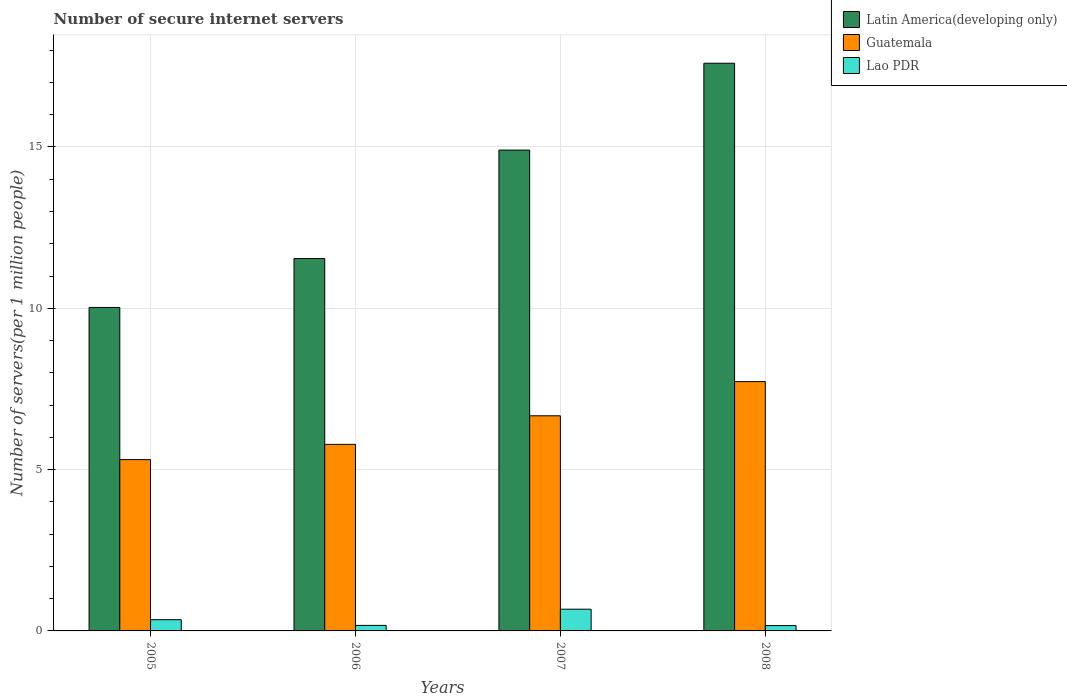Are the number of bars per tick equal to the number of legend labels?
Make the answer very short. Yes. Are the number of bars on each tick of the X-axis equal?
Provide a succinct answer. Yes. How many bars are there on the 2nd tick from the right?
Provide a succinct answer. 3. What is the number of secure internet servers in Guatemala in 2005?
Keep it short and to the point. 5.31. Across all years, what is the maximum number of secure internet servers in Guatemala?
Your response must be concise. 7.73. Across all years, what is the minimum number of secure internet servers in Guatemala?
Your answer should be very brief. 5.31. What is the total number of secure internet servers in Latin America(developing only) in the graph?
Your answer should be very brief. 54.06. What is the difference between the number of secure internet servers in Guatemala in 2005 and that in 2007?
Give a very brief answer. -1.36. What is the difference between the number of secure internet servers in Latin America(developing only) in 2008 and the number of secure internet servers in Lao PDR in 2006?
Your answer should be very brief. 17.42. What is the average number of secure internet servers in Latin America(developing only) per year?
Your answer should be compact. 13.52. In the year 2006, what is the difference between the number of secure internet servers in Guatemala and number of secure internet servers in Lao PDR?
Offer a terse response. 5.61. What is the ratio of the number of secure internet servers in Lao PDR in 2005 to that in 2008?
Your answer should be compact. 2.1. Is the number of secure internet servers in Guatemala in 2005 less than that in 2006?
Keep it short and to the point. Yes. What is the difference between the highest and the second highest number of secure internet servers in Latin America(developing only)?
Keep it short and to the point. 2.69. What is the difference between the highest and the lowest number of secure internet servers in Guatemala?
Your answer should be compact. 2.42. In how many years, is the number of secure internet servers in Latin America(developing only) greater than the average number of secure internet servers in Latin America(developing only) taken over all years?
Make the answer very short. 2. What does the 3rd bar from the left in 2007 represents?
Give a very brief answer. Lao PDR. What does the 2nd bar from the right in 2006 represents?
Your response must be concise. Guatemala. How many bars are there?
Ensure brevity in your answer.  12. Are all the bars in the graph horizontal?
Ensure brevity in your answer.  No. Does the graph contain grids?
Keep it short and to the point. Yes. How many legend labels are there?
Your answer should be compact. 3. What is the title of the graph?
Offer a terse response. Number of secure internet servers. What is the label or title of the Y-axis?
Offer a terse response. Number of servers(per 1 million people). What is the Number of servers(per 1 million people) of Latin America(developing only) in 2005?
Offer a very short reply. 10.03. What is the Number of servers(per 1 million people) in Guatemala in 2005?
Make the answer very short. 5.31. What is the Number of servers(per 1 million people) of Lao PDR in 2005?
Give a very brief answer. 0.35. What is the Number of servers(per 1 million people) of Latin America(developing only) in 2006?
Make the answer very short. 11.54. What is the Number of servers(per 1 million people) of Guatemala in 2006?
Offer a terse response. 5.78. What is the Number of servers(per 1 million people) in Lao PDR in 2006?
Provide a short and direct response. 0.17. What is the Number of servers(per 1 million people) in Latin America(developing only) in 2007?
Provide a short and direct response. 14.9. What is the Number of servers(per 1 million people) of Guatemala in 2007?
Your answer should be compact. 6.67. What is the Number of servers(per 1 million people) of Lao PDR in 2007?
Offer a very short reply. 0.67. What is the Number of servers(per 1 million people) of Latin America(developing only) in 2008?
Make the answer very short. 17.59. What is the Number of servers(per 1 million people) in Guatemala in 2008?
Provide a succinct answer. 7.73. What is the Number of servers(per 1 million people) of Lao PDR in 2008?
Offer a terse response. 0.17. Across all years, what is the maximum Number of servers(per 1 million people) of Latin America(developing only)?
Offer a terse response. 17.59. Across all years, what is the maximum Number of servers(per 1 million people) of Guatemala?
Your answer should be very brief. 7.73. Across all years, what is the maximum Number of servers(per 1 million people) of Lao PDR?
Give a very brief answer. 0.67. Across all years, what is the minimum Number of servers(per 1 million people) in Latin America(developing only)?
Your response must be concise. 10.03. Across all years, what is the minimum Number of servers(per 1 million people) in Guatemala?
Ensure brevity in your answer.  5.31. Across all years, what is the minimum Number of servers(per 1 million people) in Lao PDR?
Provide a succinct answer. 0.17. What is the total Number of servers(per 1 million people) of Latin America(developing only) in the graph?
Ensure brevity in your answer.  54.06. What is the total Number of servers(per 1 million people) of Guatemala in the graph?
Offer a very short reply. 25.49. What is the total Number of servers(per 1 million people) of Lao PDR in the graph?
Give a very brief answer. 1.36. What is the difference between the Number of servers(per 1 million people) in Latin America(developing only) in 2005 and that in 2006?
Your answer should be compact. -1.52. What is the difference between the Number of servers(per 1 million people) of Guatemala in 2005 and that in 2006?
Give a very brief answer. -0.47. What is the difference between the Number of servers(per 1 million people) of Lao PDR in 2005 and that in 2006?
Ensure brevity in your answer.  0.18. What is the difference between the Number of servers(per 1 million people) in Latin America(developing only) in 2005 and that in 2007?
Your answer should be very brief. -4.88. What is the difference between the Number of servers(per 1 million people) of Guatemala in 2005 and that in 2007?
Your response must be concise. -1.36. What is the difference between the Number of servers(per 1 million people) in Lao PDR in 2005 and that in 2007?
Make the answer very short. -0.33. What is the difference between the Number of servers(per 1 million people) of Latin America(developing only) in 2005 and that in 2008?
Your answer should be compact. -7.57. What is the difference between the Number of servers(per 1 million people) in Guatemala in 2005 and that in 2008?
Provide a short and direct response. -2.42. What is the difference between the Number of servers(per 1 million people) of Lao PDR in 2005 and that in 2008?
Keep it short and to the point. 0.18. What is the difference between the Number of servers(per 1 million people) of Latin America(developing only) in 2006 and that in 2007?
Provide a short and direct response. -3.36. What is the difference between the Number of servers(per 1 million people) of Guatemala in 2006 and that in 2007?
Give a very brief answer. -0.89. What is the difference between the Number of servers(per 1 million people) of Lao PDR in 2006 and that in 2007?
Provide a short and direct response. -0.5. What is the difference between the Number of servers(per 1 million people) of Latin America(developing only) in 2006 and that in 2008?
Your answer should be very brief. -6.05. What is the difference between the Number of servers(per 1 million people) in Guatemala in 2006 and that in 2008?
Provide a succinct answer. -1.94. What is the difference between the Number of servers(per 1 million people) of Lao PDR in 2006 and that in 2008?
Provide a short and direct response. 0.01. What is the difference between the Number of servers(per 1 million people) of Latin America(developing only) in 2007 and that in 2008?
Give a very brief answer. -2.69. What is the difference between the Number of servers(per 1 million people) of Guatemala in 2007 and that in 2008?
Offer a very short reply. -1.06. What is the difference between the Number of servers(per 1 million people) of Lao PDR in 2007 and that in 2008?
Offer a very short reply. 0.51. What is the difference between the Number of servers(per 1 million people) in Latin America(developing only) in 2005 and the Number of servers(per 1 million people) in Guatemala in 2006?
Ensure brevity in your answer.  4.24. What is the difference between the Number of servers(per 1 million people) of Latin America(developing only) in 2005 and the Number of servers(per 1 million people) of Lao PDR in 2006?
Make the answer very short. 9.85. What is the difference between the Number of servers(per 1 million people) of Guatemala in 2005 and the Number of servers(per 1 million people) of Lao PDR in 2006?
Your answer should be very brief. 5.14. What is the difference between the Number of servers(per 1 million people) in Latin America(developing only) in 2005 and the Number of servers(per 1 million people) in Guatemala in 2007?
Give a very brief answer. 3.36. What is the difference between the Number of servers(per 1 million people) of Latin America(developing only) in 2005 and the Number of servers(per 1 million people) of Lao PDR in 2007?
Ensure brevity in your answer.  9.35. What is the difference between the Number of servers(per 1 million people) of Guatemala in 2005 and the Number of servers(per 1 million people) of Lao PDR in 2007?
Keep it short and to the point. 4.64. What is the difference between the Number of servers(per 1 million people) in Latin America(developing only) in 2005 and the Number of servers(per 1 million people) in Guatemala in 2008?
Your answer should be compact. 2.3. What is the difference between the Number of servers(per 1 million people) in Latin America(developing only) in 2005 and the Number of servers(per 1 million people) in Lao PDR in 2008?
Your answer should be compact. 9.86. What is the difference between the Number of servers(per 1 million people) of Guatemala in 2005 and the Number of servers(per 1 million people) of Lao PDR in 2008?
Your answer should be very brief. 5.14. What is the difference between the Number of servers(per 1 million people) of Latin America(developing only) in 2006 and the Number of servers(per 1 million people) of Guatemala in 2007?
Your response must be concise. 4.87. What is the difference between the Number of servers(per 1 million people) of Latin America(developing only) in 2006 and the Number of servers(per 1 million people) of Lao PDR in 2007?
Your answer should be compact. 10.87. What is the difference between the Number of servers(per 1 million people) in Guatemala in 2006 and the Number of servers(per 1 million people) in Lao PDR in 2007?
Your answer should be compact. 5.11. What is the difference between the Number of servers(per 1 million people) of Latin America(developing only) in 2006 and the Number of servers(per 1 million people) of Guatemala in 2008?
Offer a very short reply. 3.82. What is the difference between the Number of servers(per 1 million people) of Latin America(developing only) in 2006 and the Number of servers(per 1 million people) of Lao PDR in 2008?
Provide a succinct answer. 11.38. What is the difference between the Number of servers(per 1 million people) in Guatemala in 2006 and the Number of servers(per 1 million people) in Lao PDR in 2008?
Keep it short and to the point. 5.62. What is the difference between the Number of servers(per 1 million people) in Latin America(developing only) in 2007 and the Number of servers(per 1 million people) in Guatemala in 2008?
Your response must be concise. 7.18. What is the difference between the Number of servers(per 1 million people) in Latin America(developing only) in 2007 and the Number of servers(per 1 million people) in Lao PDR in 2008?
Give a very brief answer. 14.74. What is the difference between the Number of servers(per 1 million people) of Guatemala in 2007 and the Number of servers(per 1 million people) of Lao PDR in 2008?
Ensure brevity in your answer.  6.5. What is the average Number of servers(per 1 million people) in Latin America(developing only) per year?
Keep it short and to the point. 13.52. What is the average Number of servers(per 1 million people) of Guatemala per year?
Offer a very short reply. 6.37. What is the average Number of servers(per 1 million people) of Lao PDR per year?
Offer a terse response. 0.34. In the year 2005, what is the difference between the Number of servers(per 1 million people) in Latin America(developing only) and Number of servers(per 1 million people) in Guatemala?
Ensure brevity in your answer.  4.72. In the year 2005, what is the difference between the Number of servers(per 1 million people) in Latin America(developing only) and Number of servers(per 1 million people) in Lao PDR?
Your answer should be compact. 9.68. In the year 2005, what is the difference between the Number of servers(per 1 million people) in Guatemala and Number of servers(per 1 million people) in Lao PDR?
Offer a terse response. 4.96. In the year 2006, what is the difference between the Number of servers(per 1 million people) in Latin America(developing only) and Number of servers(per 1 million people) in Guatemala?
Ensure brevity in your answer.  5.76. In the year 2006, what is the difference between the Number of servers(per 1 million people) of Latin America(developing only) and Number of servers(per 1 million people) of Lao PDR?
Keep it short and to the point. 11.37. In the year 2006, what is the difference between the Number of servers(per 1 million people) of Guatemala and Number of servers(per 1 million people) of Lao PDR?
Offer a terse response. 5.61. In the year 2007, what is the difference between the Number of servers(per 1 million people) of Latin America(developing only) and Number of servers(per 1 million people) of Guatemala?
Provide a succinct answer. 8.24. In the year 2007, what is the difference between the Number of servers(per 1 million people) in Latin America(developing only) and Number of servers(per 1 million people) in Lao PDR?
Offer a very short reply. 14.23. In the year 2007, what is the difference between the Number of servers(per 1 million people) in Guatemala and Number of servers(per 1 million people) in Lao PDR?
Keep it short and to the point. 5.99. In the year 2008, what is the difference between the Number of servers(per 1 million people) of Latin America(developing only) and Number of servers(per 1 million people) of Guatemala?
Ensure brevity in your answer.  9.87. In the year 2008, what is the difference between the Number of servers(per 1 million people) in Latin America(developing only) and Number of servers(per 1 million people) in Lao PDR?
Your answer should be compact. 17.43. In the year 2008, what is the difference between the Number of servers(per 1 million people) of Guatemala and Number of servers(per 1 million people) of Lao PDR?
Make the answer very short. 7.56. What is the ratio of the Number of servers(per 1 million people) of Latin America(developing only) in 2005 to that in 2006?
Give a very brief answer. 0.87. What is the ratio of the Number of servers(per 1 million people) in Guatemala in 2005 to that in 2006?
Provide a succinct answer. 0.92. What is the ratio of the Number of servers(per 1 million people) of Lao PDR in 2005 to that in 2006?
Offer a terse response. 2.03. What is the ratio of the Number of servers(per 1 million people) in Latin America(developing only) in 2005 to that in 2007?
Provide a short and direct response. 0.67. What is the ratio of the Number of servers(per 1 million people) of Guatemala in 2005 to that in 2007?
Your answer should be compact. 0.8. What is the ratio of the Number of servers(per 1 million people) in Lao PDR in 2005 to that in 2007?
Your answer should be compact. 0.52. What is the ratio of the Number of servers(per 1 million people) of Latin America(developing only) in 2005 to that in 2008?
Provide a succinct answer. 0.57. What is the ratio of the Number of servers(per 1 million people) in Guatemala in 2005 to that in 2008?
Keep it short and to the point. 0.69. What is the ratio of the Number of servers(per 1 million people) in Lao PDR in 2005 to that in 2008?
Your answer should be compact. 2.1. What is the ratio of the Number of servers(per 1 million people) of Latin America(developing only) in 2006 to that in 2007?
Offer a terse response. 0.77. What is the ratio of the Number of servers(per 1 million people) in Guatemala in 2006 to that in 2007?
Give a very brief answer. 0.87. What is the ratio of the Number of servers(per 1 million people) of Lao PDR in 2006 to that in 2007?
Offer a very short reply. 0.25. What is the ratio of the Number of servers(per 1 million people) of Latin America(developing only) in 2006 to that in 2008?
Your response must be concise. 0.66. What is the ratio of the Number of servers(per 1 million people) in Guatemala in 2006 to that in 2008?
Your answer should be very brief. 0.75. What is the ratio of the Number of servers(per 1 million people) in Lao PDR in 2006 to that in 2008?
Make the answer very short. 1.04. What is the ratio of the Number of servers(per 1 million people) of Latin America(developing only) in 2007 to that in 2008?
Make the answer very short. 0.85. What is the ratio of the Number of servers(per 1 million people) in Guatemala in 2007 to that in 2008?
Your answer should be compact. 0.86. What is the ratio of the Number of servers(per 1 million people) in Lao PDR in 2007 to that in 2008?
Keep it short and to the point. 4.07. What is the difference between the highest and the second highest Number of servers(per 1 million people) of Latin America(developing only)?
Keep it short and to the point. 2.69. What is the difference between the highest and the second highest Number of servers(per 1 million people) in Guatemala?
Provide a short and direct response. 1.06. What is the difference between the highest and the second highest Number of servers(per 1 million people) in Lao PDR?
Offer a terse response. 0.33. What is the difference between the highest and the lowest Number of servers(per 1 million people) of Latin America(developing only)?
Provide a short and direct response. 7.57. What is the difference between the highest and the lowest Number of servers(per 1 million people) in Guatemala?
Provide a short and direct response. 2.42. What is the difference between the highest and the lowest Number of servers(per 1 million people) of Lao PDR?
Provide a short and direct response. 0.51. 